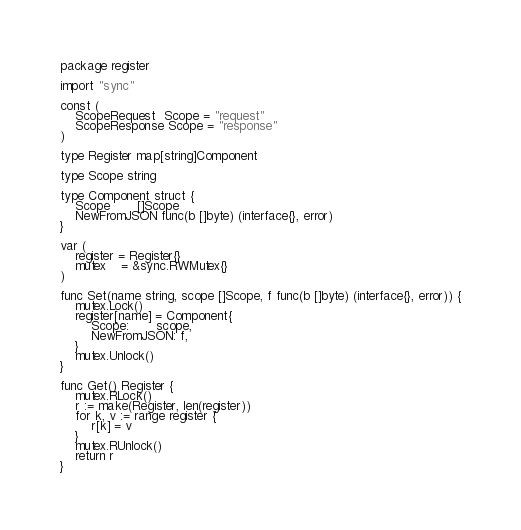Convert code to text. <code><loc_0><loc_0><loc_500><loc_500><_Go_>package register

import "sync"

const (
	ScopeRequest  Scope = "request"
	ScopeResponse Scope = "response"
)

type Register map[string]Component

type Scope string

type Component struct {
	Scope       []Scope
	NewFromJSON func(b []byte) (interface{}, error)
}

var (
	register = Register{}
	mutex    = &sync.RWMutex{}
)

func Set(name string, scope []Scope, f func(b []byte) (interface{}, error)) {
	mutex.Lock()
	register[name] = Component{
		Scope:       scope,
		NewFromJSON: f,
	}
	mutex.Unlock()
}

func Get() Register {
	mutex.RLock()
	r := make(Register, len(register))
	for k, v := range register {
		r[k] = v
	}
	mutex.RUnlock()
	return r
}
</code> 